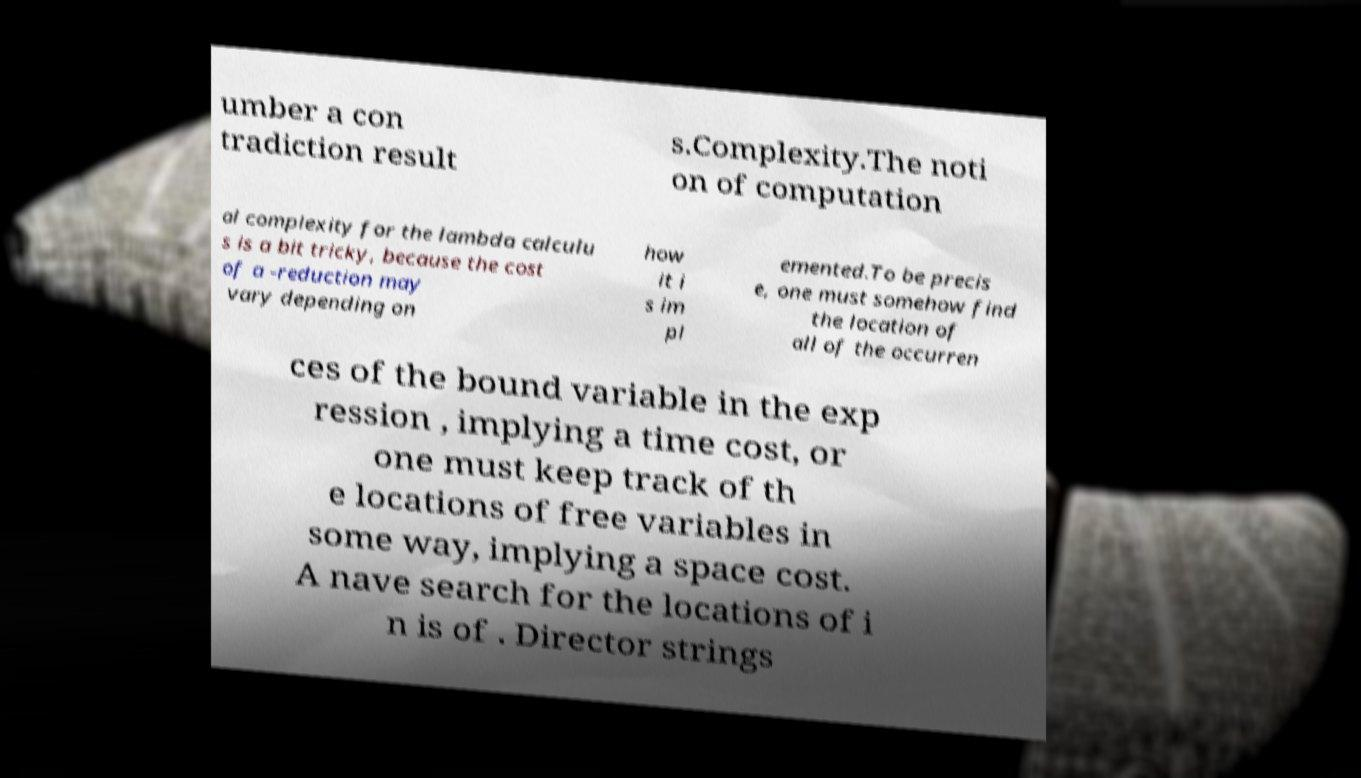Please identify and transcribe the text found in this image. umber a con tradiction result s.Complexity.The noti on of computation al complexity for the lambda calculu s is a bit tricky, because the cost of a -reduction may vary depending on how it i s im pl emented.To be precis e, one must somehow find the location of all of the occurren ces of the bound variable in the exp ression , implying a time cost, or one must keep track of th e locations of free variables in some way, implying a space cost. A nave search for the locations of i n is of . Director strings 